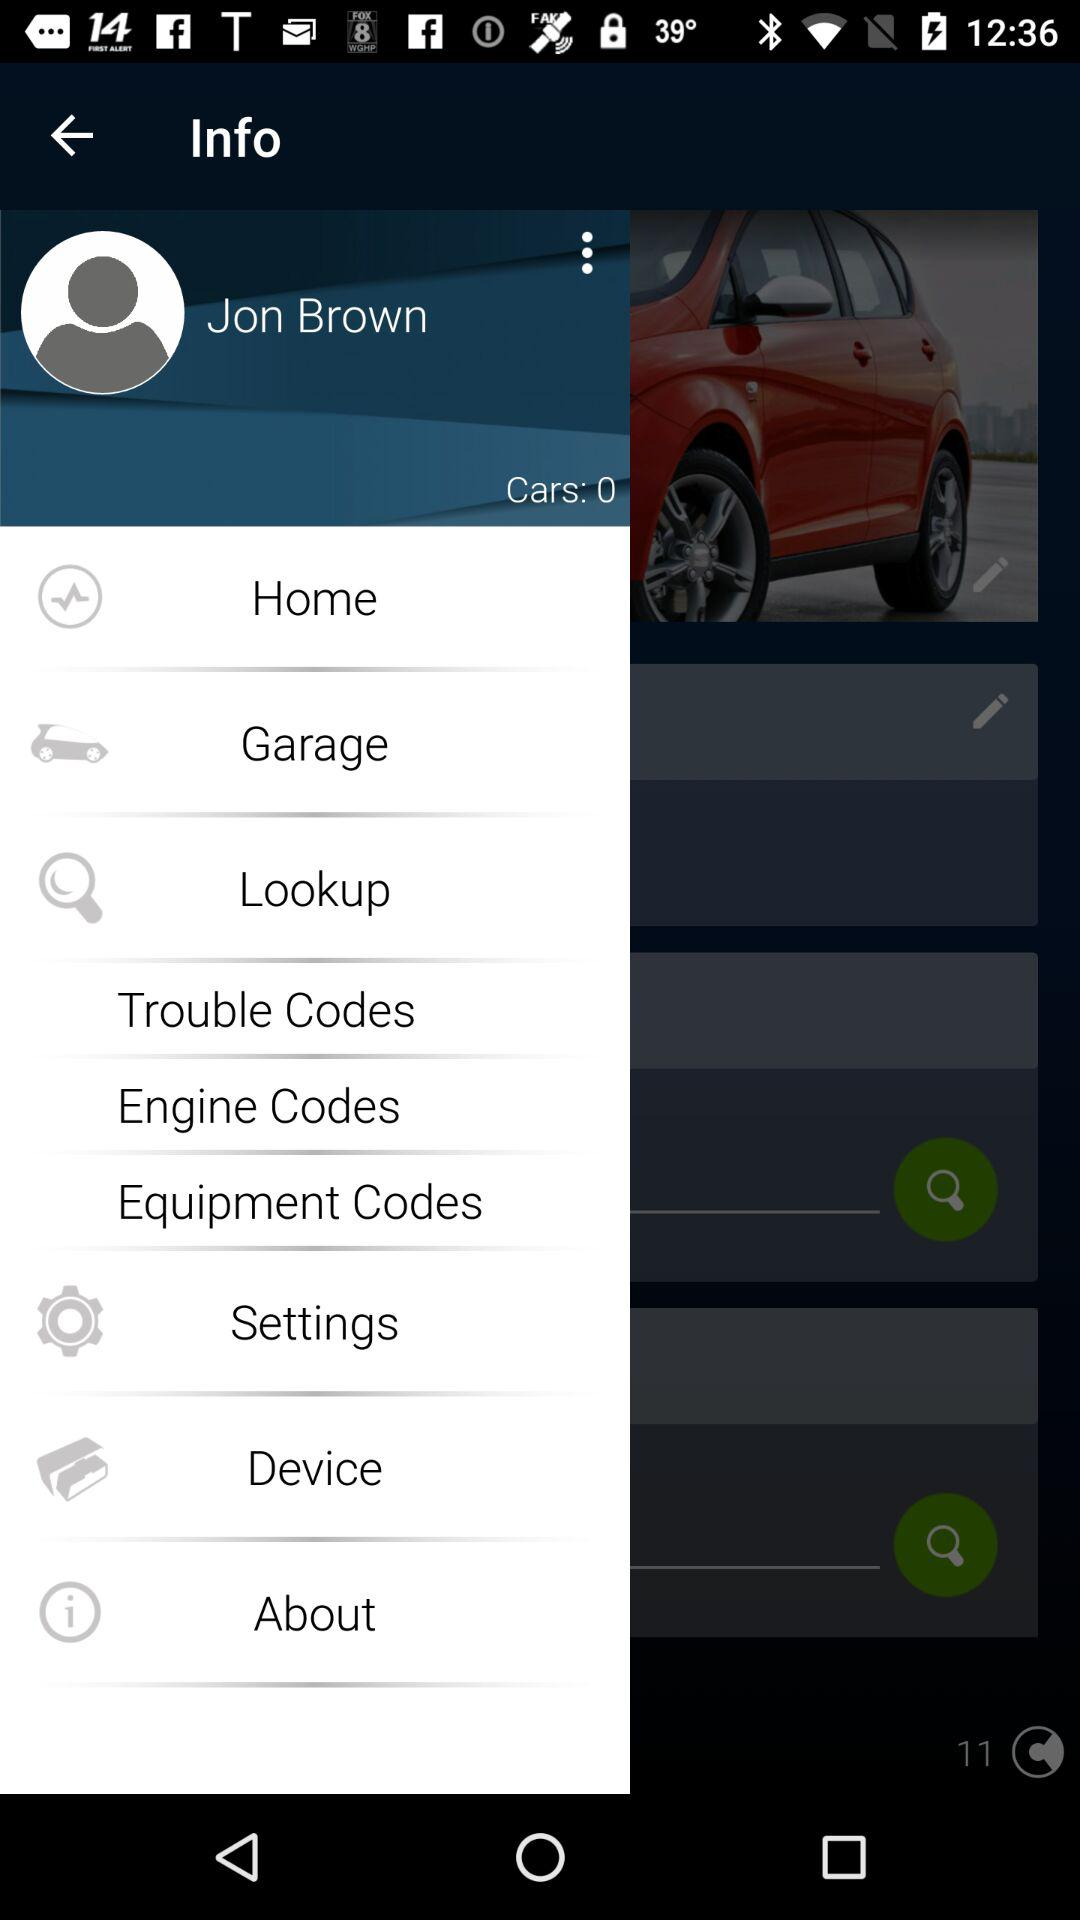What is the name of the user? The name of the user is Jon Brown. 